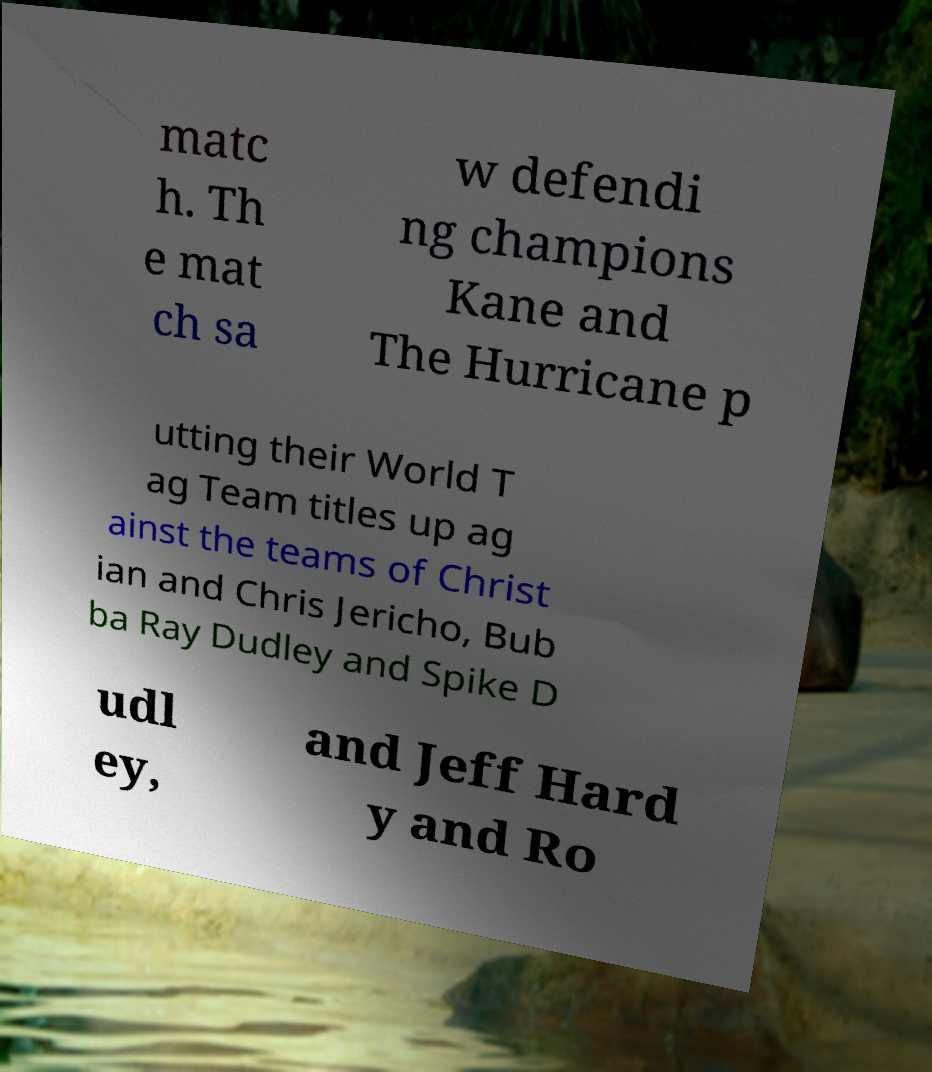Please read and relay the text visible in this image. What does it say? matc h. Th e mat ch sa w defendi ng champions Kane and The Hurricane p utting their World T ag Team titles up ag ainst the teams of Christ ian and Chris Jericho, Bub ba Ray Dudley and Spike D udl ey, and Jeff Hard y and Ro 